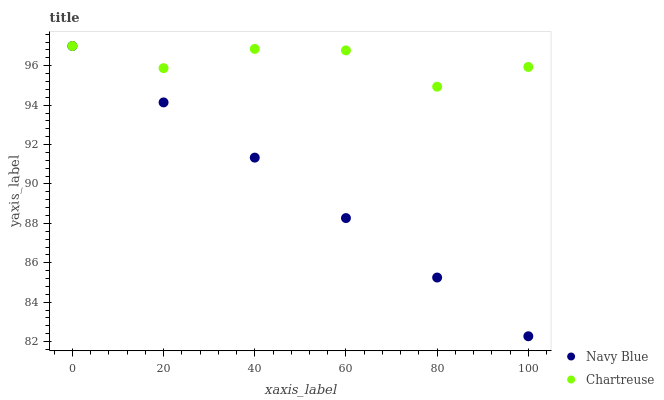Does Navy Blue have the minimum area under the curve?
Answer yes or no. Yes. Does Chartreuse have the maximum area under the curve?
Answer yes or no. Yes. Does Chartreuse have the minimum area under the curve?
Answer yes or no. No. Is Navy Blue the smoothest?
Answer yes or no. Yes. Is Chartreuse the roughest?
Answer yes or no. Yes. Is Chartreuse the smoothest?
Answer yes or no. No. Does Navy Blue have the lowest value?
Answer yes or no. Yes. Does Chartreuse have the lowest value?
Answer yes or no. No. Does Chartreuse have the highest value?
Answer yes or no. Yes. Does Chartreuse intersect Navy Blue?
Answer yes or no. Yes. Is Chartreuse less than Navy Blue?
Answer yes or no. No. Is Chartreuse greater than Navy Blue?
Answer yes or no. No. 